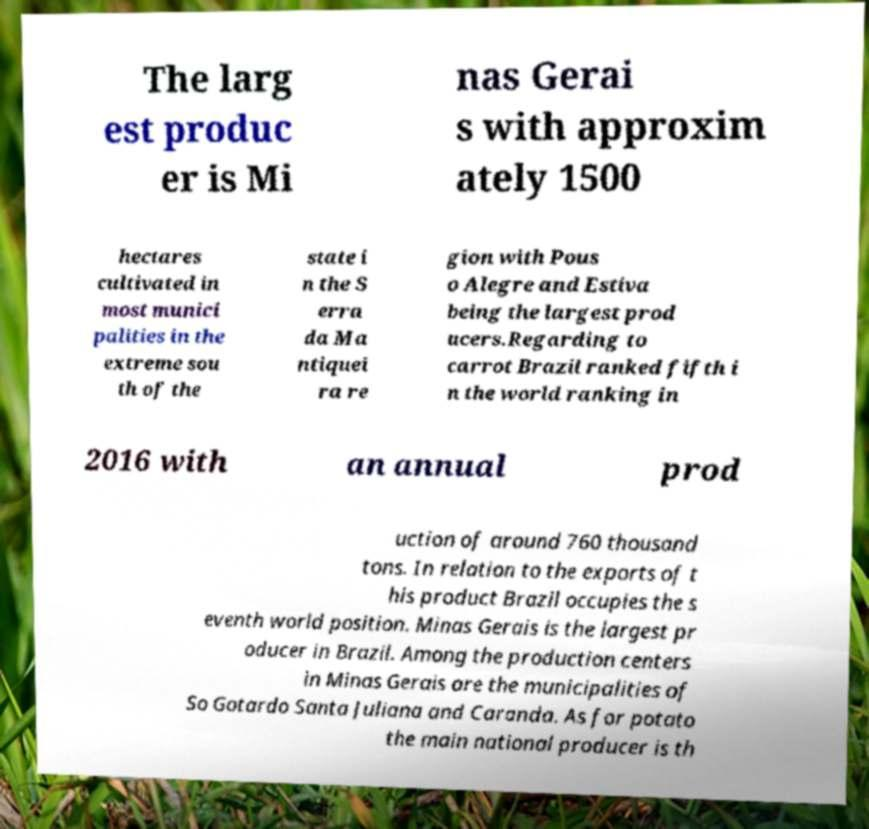Could you assist in decoding the text presented in this image and type it out clearly? The larg est produc er is Mi nas Gerai s with approxim ately 1500 hectares cultivated in most munici palities in the extreme sou th of the state i n the S erra da Ma ntiquei ra re gion with Pous o Alegre and Estiva being the largest prod ucers.Regarding to carrot Brazil ranked fifth i n the world ranking in 2016 with an annual prod uction of around 760 thousand tons. In relation to the exports of t his product Brazil occupies the s eventh world position. Minas Gerais is the largest pr oducer in Brazil. Among the production centers in Minas Gerais are the municipalities of So Gotardo Santa Juliana and Caranda. As for potato the main national producer is th 